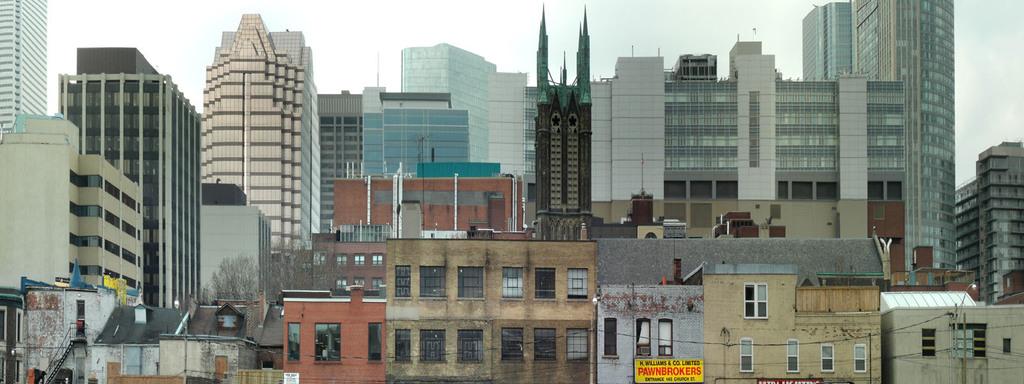What kind of business is advertised on the yellow sign?
Provide a short and direct response. Unanswerable. 